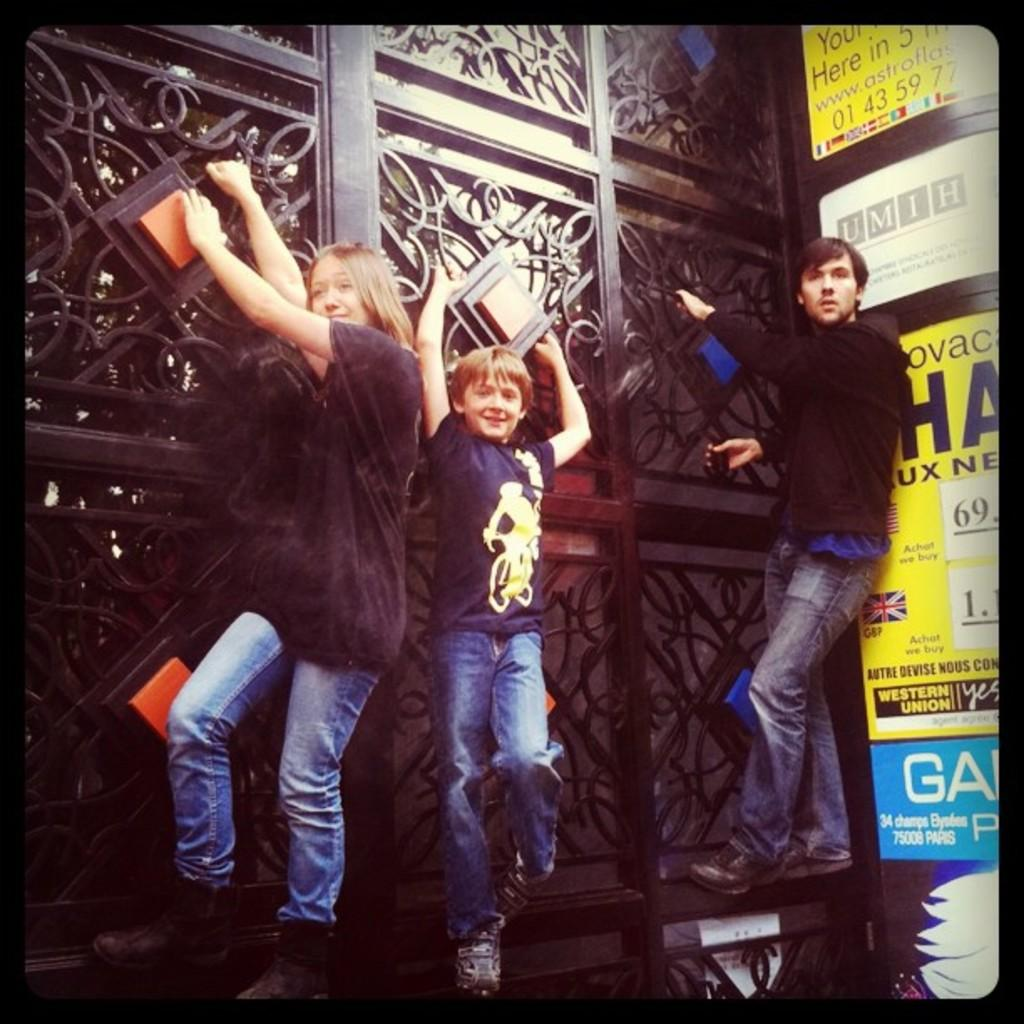How many people are present in the image? There are three people in the image. What are the people doing in the image? The people are holding a gate and standing on it. What type of image is this, based on the provided facts? The image appears to be a hoarding. What type of doctor is standing on the gate in the image? There is no doctor present in the image; it features three people holding and standing on a gate. Is there a girl wearing a mitten in the image? There is no girl or mitten mentioned in the provided facts, so we cannot determine if they are present in the image. 